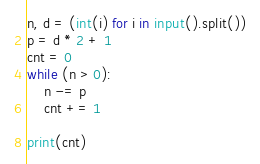Convert code to text. <code><loc_0><loc_0><loc_500><loc_500><_Python_>n, d = (int(i) for i in input().split())
p = d * 2 + 1
cnt = 0
while (n > 0):
    n -= p
    cnt += 1

print(cnt)</code> 